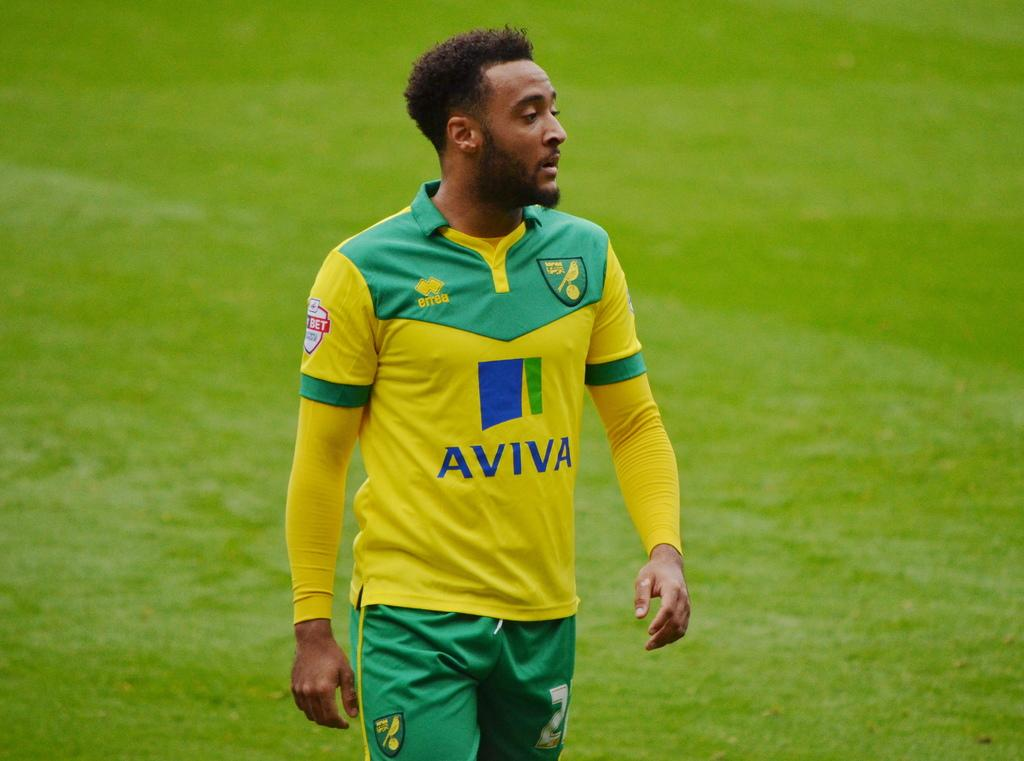Who is present in the image? There is a man in the image. What type of surface is visible on the ground in the image? There is grass on the ground in the image. What type of suit is the kitten wearing in the image? There is no kitten present in the image, and therefore no suit can be observed. Can you tell me the color of the badge on the man's shirt in the image? The provided facts do not mention a badge on the man's shirt, so we cannot determine its color. 